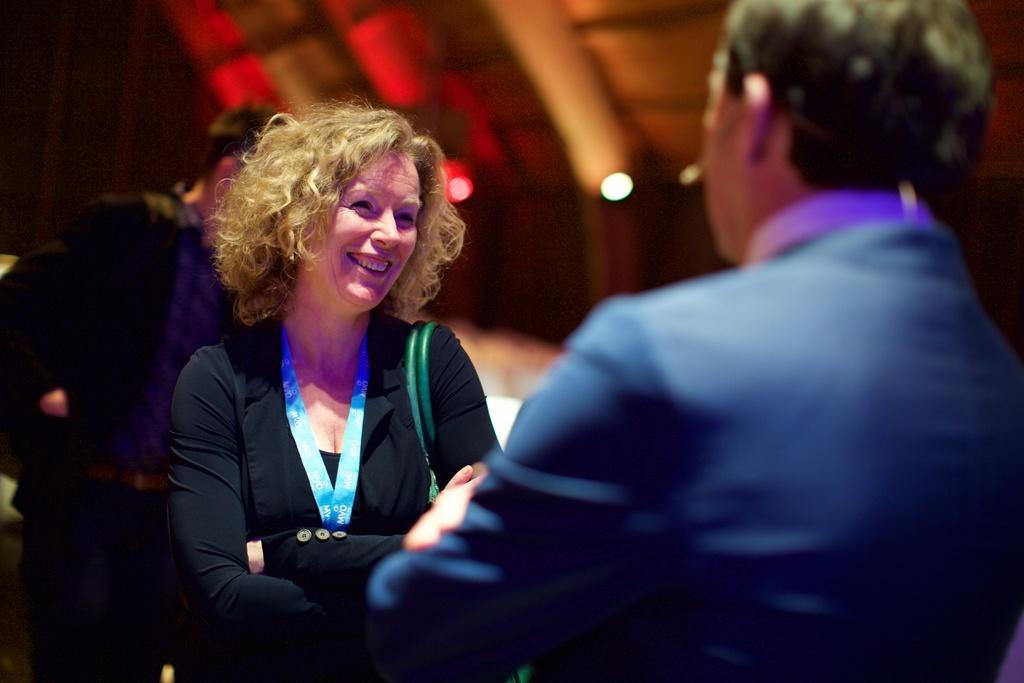Could you give a brief overview of what you see in this image? The foreground is blurred. In the middle we can see a woman. On the left we can see a person. The background is blurred. 